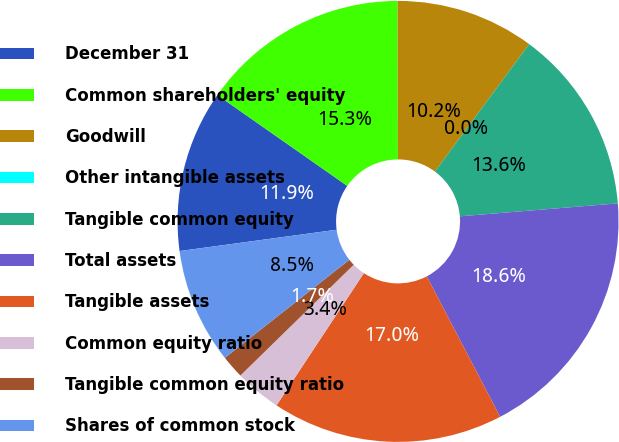<chart> <loc_0><loc_0><loc_500><loc_500><pie_chart><fcel>December 31<fcel>Common shareholders' equity<fcel>Goodwill<fcel>Other intangible assets<fcel>Tangible common equity<fcel>Total assets<fcel>Tangible assets<fcel>Common equity ratio<fcel>Tangible common equity ratio<fcel>Shares of common stock<nl><fcel>11.86%<fcel>15.25%<fcel>10.17%<fcel>0.0%<fcel>13.56%<fcel>18.64%<fcel>16.95%<fcel>3.39%<fcel>1.7%<fcel>8.47%<nl></chart> 